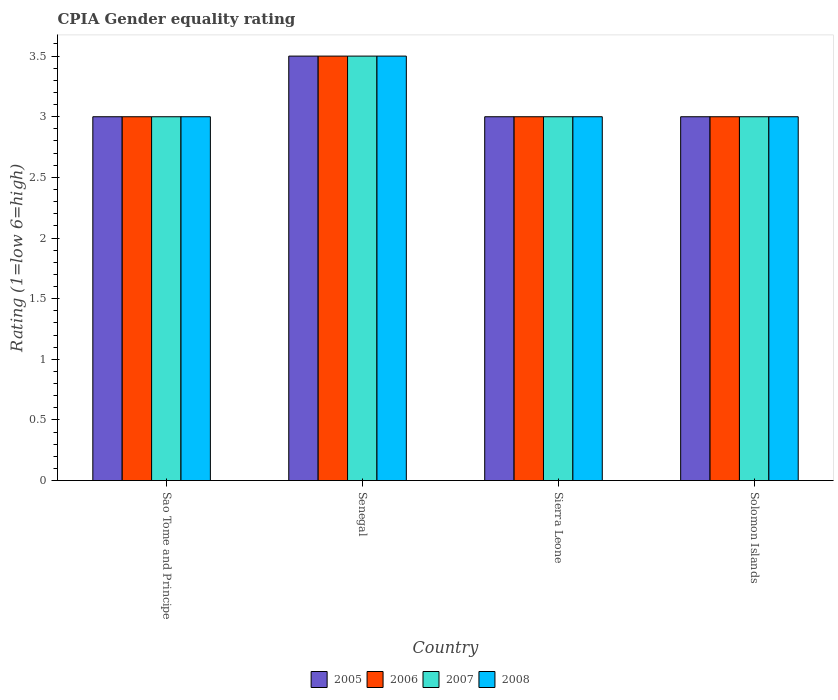How many different coloured bars are there?
Give a very brief answer. 4. How many bars are there on the 1st tick from the left?
Offer a very short reply. 4. What is the label of the 1st group of bars from the left?
Your answer should be very brief. Sao Tome and Principe. In how many cases, is the number of bars for a given country not equal to the number of legend labels?
Keep it short and to the point. 0. Across all countries, what is the maximum CPIA rating in 2005?
Keep it short and to the point. 3.5. Across all countries, what is the minimum CPIA rating in 2007?
Your answer should be compact. 3. In which country was the CPIA rating in 2006 maximum?
Provide a succinct answer. Senegal. In which country was the CPIA rating in 2005 minimum?
Ensure brevity in your answer.  Sao Tome and Principe. What is the difference between the CPIA rating in 2006 in Senegal and that in Sierra Leone?
Provide a short and direct response. 0.5. What is the difference between the CPIA rating in 2005 in Sao Tome and Principe and the CPIA rating in 2008 in Senegal?
Your answer should be very brief. -0.5. What is the average CPIA rating in 2005 per country?
Offer a very short reply. 3.12. Is the difference between the CPIA rating in 2005 in Senegal and Sierra Leone greater than the difference between the CPIA rating in 2007 in Senegal and Sierra Leone?
Offer a terse response. No. What is the difference between the highest and the second highest CPIA rating in 2006?
Offer a terse response. -0.5. Is the sum of the CPIA rating in 2005 in Sao Tome and Principe and Senegal greater than the maximum CPIA rating in 2006 across all countries?
Offer a very short reply. Yes. Is it the case that in every country, the sum of the CPIA rating in 2007 and CPIA rating in 2005 is greater than the sum of CPIA rating in 2008 and CPIA rating in 2006?
Make the answer very short. No. What does the 2nd bar from the right in Sierra Leone represents?
Provide a short and direct response. 2007. Is it the case that in every country, the sum of the CPIA rating in 2006 and CPIA rating in 2008 is greater than the CPIA rating in 2005?
Your answer should be compact. Yes. How many countries are there in the graph?
Provide a succinct answer. 4. What is the difference between two consecutive major ticks on the Y-axis?
Make the answer very short. 0.5. Does the graph contain grids?
Give a very brief answer. No. How are the legend labels stacked?
Make the answer very short. Horizontal. What is the title of the graph?
Your answer should be very brief. CPIA Gender equality rating. Does "1982" appear as one of the legend labels in the graph?
Provide a short and direct response. No. What is the label or title of the X-axis?
Your response must be concise. Country. What is the Rating (1=low 6=high) in 2005 in Sao Tome and Principe?
Provide a short and direct response. 3. What is the Rating (1=low 6=high) of 2007 in Sao Tome and Principe?
Your response must be concise. 3. What is the Rating (1=low 6=high) in 2006 in Senegal?
Give a very brief answer. 3.5. What is the Rating (1=low 6=high) in 2008 in Senegal?
Offer a terse response. 3.5. What is the Rating (1=low 6=high) of 2008 in Sierra Leone?
Offer a very short reply. 3. What is the Rating (1=low 6=high) of 2005 in Solomon Islands?
Provide a short and direct response. 3. What is the Rating (1=low 6=high) in 2006 in Solomon Islands?
Provide a short and direct response. 3. What is the Rating (1=low 6=high) in 2007 in Solomon Islands?
Your answer should be compact. 3. Across all countries, what is the maximum Rating (1=low 6=high) in 2007?
Your answer should be very brief. 3.5. Across all countries, what is the minimum Rating (1=low 6=high) of 2005?
Keep it short and to the point. 3. Across all countries, what is the minimum Rating (1=low 6=high) in 2006?
Your answer should be compact. 3. Across all countries, what is the minimum Rating (1=low 6=high) in 2007?
Ensure brevity in your answer.  3. Across all countries, what is the minimum Rating (1=low 6=high) in 2008?
Your answer should be very brief. 3. What is the total Rating (1=low 6=high) in 2006 in the graph?
Provide a short and direct response. 12.5. What is the total Rating (1=low 6=high) of 2007 in the graph?
Your answer should be very brief. 12.5. What is the total Rating (1=low 6=high) of 2008 in the graph?
Offer a terse response. 12.5. What is the difference between the Rating (1=low 6=high) of 2005 in Sao Tome and Principe and that in Senegal?
Offer a very short reply. -0.5. What is the difference between the Rating (1=low 6=high) in 2006 in Sao Tome and Principe and that in Sierra Leone?
Make the answer very short. 0. What is the difference between the Rating (1=low 6=high) of 2007 in Sao Tome and Principe and that in Sierra Leone?
Offer a terse response. 0. What is the difference between the Rating (1=low 6=high) in 2008 in Sao Tome and Principe and that in Sierra Leone?
Your response must be concise. 0. What is the difference between the Rating (1=low 6=high) in 2006 in Senegal and that in Sierra Leone?
Keep it short and to the point. 0.5. What is the difference between the Rating (1=low 6=high) in 2007 in Senegal and that in Sierra Leone?
Keep it short and to the point. 0.5. What is the difference between the Rating (1=low 6=high) of 2005 in Senegal and that in Solomon Islands?
Ensure brevity in your answer.  0.5. What is the difference between the Rating (1=low 6=high) of 2005 in Sierra Leone and that in Solomon Islands?
Your answer should be compact. 0. What is the difference between the Rating (1=low 6=high) of 2007 in Sierra Leone and that in Solomon Islands?
Your answer should be very brief. 0. What is the difference between the Rating (1=low 6=high) in 2006 in Sao Tome and Principe and the Rating (1=low 6=high) in 2007 in Senegal?
Make the answer very short. -0.5. What is the difference between the Rating (1=low 6=high) in 2005 in Sao Tome and Principe and the Rating (1=low 6=high) in 2007 in Sierra Leone?
Your answer should be compact. 0. What is the difference between the Rating (1=low 6=high) in 2005 in Sao Tome and Principe and the Rating (1=low 6=high) in 2008 in Sierra Leone?
Ensure brevity in your answer.  0. What is the difference between the Rating (1=low 6=high) of 2006 in Sao Tome and Principe and the Rating (1=low 6=high) of 2008 in Sierra Leone?
Your response must be concise. 0. What is the difference between the Rating (1=low 6=high) of 2007 in Sao Tome and Principe and the Rating (1=low 6=high) of 2008 in Sierra Leone?
Offer a very short reply. 0. What is the difference between the Rating (1=low 6=high) of 2005 in Sao Tome and Principe and the Rating (1=low 6=high) of 2007 in Solomon Islands?
Your answer should be compact. 0. What is the difference between the Rating (1=low 6=high) of 2006 in Sao Tome and Principe and the Rating (1=low 6=high) of 2008 in Solomon Islands?
Provide a short and direct response. 0. What is the difference between the Rating (1=low 6=high) of 2007 in Sao Tome and Principe and the Rating (1=low 6=high) of 2008 in Solomon Islands?
Your answer should be very brief. 0. What is the difference between the Rating (1=low 6=high) of 2005 in Senegal and the Rating (1=low 6=high) of 2008 in Sierra Leone?
Your response must be concise. 0.5. What is the difference between the Rating (1=low 6=high) in 2006 in Senegal and the Rating (1=low 6=high) in 2008 in Sierra Leone?
Give a very brief answer. 0.5. What is the difference between the Rating (1=low 6=high) in 2005 in Senegal and the Rating (1=low 6=high) in 2007 in Solomon Islands?
Give a very brief answer. 0.5. What is the difference between the Rating (1=low 6=high) in 2006 in Senegal and the Rating (1=low 6=high) in 2007 in Solomon Islands?
Your answer should be compact. 0.5. What is the difference between the Rating (1=low 6=high) of 2005 in Sierra Leone and the Rating (1=low 6=high) of 2007 in Solomon Islands?
Keep it short and to the point. 0. What is the difference between the Rating (1=low 6=high) in 2006 in Sierra Leone and the Rating (1=low 6=high) in 2007 in Solomon Islands?
Give a very brief answer. 0. What is the difference between the Rating (1=low 6=high) of 2007 in Sierra Leone and the Rating (1=low 6=high) of 2008 in Solomon Islands?
Offer a very short reply. 0. What is the average Rating (1=low 6=high) of 2005 per country?
Provide a short and direct response. 3.12. What is the average Rating (1=low 6=high) of 2006 per country?
Ensure brevity in your answer.  3.12. What is the average Rating (1=low 6=high) in 2007 per country?
Offer a terse response. 3.12. What is the average Rating (1=low 6=high) of 2008 per country?
Offer a terse response. 3.12. What is the difference between the Rating (1=low 6=high) in 2005 and Rating (1=low 6=high) in 2006 in Sao Tome and Principe?
Your response must be concise. 0. What is the difference between the Rating (1=low 6=high) in 2005 and Rating (1=low 6=high) in 2007 in Sao Tome and Principe?
Make the answer very short. 0. What is the difference between the Rating (1=low 6=high) in 2007 and Rating (1=low 6=high) in 2008 in Sao Tome and Principe?
Your answer should be compact. 0. What is the difference between the Rating (1=low 6=high) of 2005 and Rating (1=low 6=high) of 2007 in Senegal?
Your answer should be very brief. 0. What is the difference between the Rating (1=low 6=high) in 2006 and Rating (1=low 6=high) in 2007 in Senegal?
Give a very brief answer. 0. What is the difference between the Rating (1=low 6=high) in 2006 and Rating (1=low 6=high) in 2008 in Senegal?
Offer a terse response. 0. What is the difference between the Rating (1=low 6=high) of 2007 and Rating (1=low 6=high) of 2008 in Senegal?
Your response must be concise. 0. What is the difference between the Rating (1=low 6=high) in 2005 and Rating (1=low 6=high) in 2006 in Sierra Leone?
Offer a terse response. 0. What is the difference between the Rating (1=low 6=high) in 2005 and Rating (1=low 6=high) in 2007 in Sierra Leone?
Give a very brief answer. 0. What is the difference between the Rating (1=low 6=high) of 2005 and Rating (1=low 6=high) of 2008 in Sierra Leone?
Ensure brevity in your answer.  0. What is the difference between the Rating (1=low 6=high) of 2007 and Rating (1=low 6=high) of 2008 in Sierra Leone?
Offer a very short reply. 0. What is the difference between the Rating (1=low 6=high) in 2005 and Rating (1=low 6=high) in 2006 in Solomon Islands?
Offer a terse response. 0. What is the difference between the Rating (1=low 6=high) of 2007 and Rating (1=low 6=high) of 2008 in Solomon Islands?
Your answer should be compact. 0. What is the ratio of the Rating (1=low 6=high) of 2005 in Sao Tome and Principe to that in Senegal?
Your answer should be compact. 0.86. What is the ratio of the Rating (1=low 6=high) in 2006 in Sao Tome and Principe to that in Senegal?
Make the answer very short. 0.86. What is the ratio of the Rating (1=low 6=high) in 2008 in Sao Tome and Principe to that in Senegal?
Offer a terse response. 0.86. What is the ratio of the Rating (1=low 6=high) of 2006 in Sao Tome and Principe to that in Sierra Leone?
Provide a short and direct response. 1. What is the ratio of the Rating (1=low 6=high) of 2007 in Sao Tome and Principe to that in Sierra Leone?
Offer a terse response. 1. What is the ratio of the Rating (1=low 6=high) of 2008 in Sao Tome and Principe to that in Sierra Leone?
Your answer should be very brief. 1. What is the ratio of the Rating (1=low 6=high) of 2006 in Sao Tome and Principe to that in Solomon Islands?
Ensure brevity in your answer.  1. What is the ratio of the Rating (1=low 6=high) of 2008 in Senegal to that in Sierra Leone?
Ensure brevity in your answer.  1.17. What is the ratio of the Rating (1=low 6=high) of 2005 in Senegal to that in Solomon Islands?
Your answer should be very brief. 1.17. What is the ratio of the Rating (1=low 6=high) of 2007 in Senegal to that in Solomon Islands?
Keep it short and to the point. 1.17. What is the ratio of the Rating (1=low 6=high) of 2007 in Sierra Leone to that in Solomon Islands?
Ensure brevity in your answer.  1. What is the ratio of the Rating (1=low 6=high) in 2008 in Sierra Leone to that in Solomon Islands?
Keep it short and to the point. 1. What is the difference between the highest and the second highest Rating (1=low 6=high) in 2005?
Offer a very short reply. 0.5. What is the difference between the highest and the second highest Rating (1=low 6=high) in 2006?
Your answer should be compact. 0.5. What is the difference between the highest and the second highest Rating (1=low 6=high) of 2007?
Offer a terse response. 0.5. What is the difference between the highest and the lowest Rating (1=low 6=high) of 2006?
Provide a short and direct response. 0.5. What is the difference between the highest and the lowest Rating (1=low 6=high) in 2007?
Your answer should be very brief. 0.5. What is the difference between the highest and the lowest Rating (1=low 6=high) of 2008?
Keep it short and to the point. 0.5. 